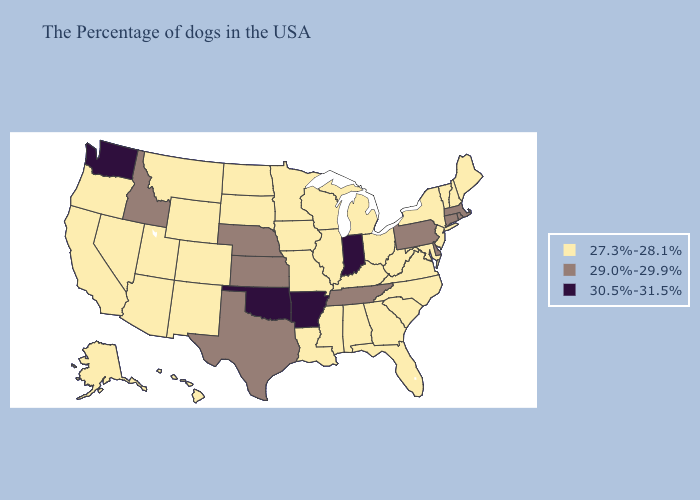Among the states that border Tennessee , which have the lowest value?
Quick response, please. Virginia, North Carolina, Georgia, Kentucky, Alabama, Mississippi, Missouri. What is the lowest value in states that border Michigan?
Keep it brief. 27.3%-28.1%. Does Mississippi have the same value as Arkansas?
Write a very short answer. No. Name the states that have a value in the range 29.0%-29.9%?
Answer briefly. Massachusetts, Rhode Island, Connecticut, Delaware, Pennsylvania, Tennessee, Kansas, Nebraska, Texas, Idaho. Among the states that border Wyoming , which have the lowest value?
Concise answer only. South Dakota, Colorado, Utah, Montana. What is the value of Alabama?
Concise answer only. 27.3%-28.1%. Among the states that border Louisiana , which have the highest value?
Answer briefly. Arkansas. Name the states that have a value in the range 29.0%-29.9%?
Answer briefly. Massachusetts, Rhode Island, Connecticut, Delaware, Pennsylvania, Tennessee, Kansas, Nebraska, Texas, Idaho. Name the states that have a value in the range 29.0%-29.9%?
Be succinct. Massachusetts, Rhode Island, Connecticut, Delaware, Pennsylvania, Tennessee, Kansas, Nebraska, Texas, Idaho. Does the map have missing data?
Be succinct. No. What is the value of Florida?
Keep it brief. 27.3%-28.1%. What is the value of Texas?
Short answer required. 29.0%-29.9%. How many symbols are there in the legend?
Keep it brief. 3. Among the states that border Iowa , which have the lowest value?
Short answer required. Wisconsin, Illinois, Missouri, Minnesota, South Dakota. Name the states that have a value in the range 29.0%-29.9%?
Short answer required. Massachusetts, Rhode Island, Connecticut, Delaware, Pennsylvania, Tennessee, Kansas, Nebraska, Texas, Idaho. 